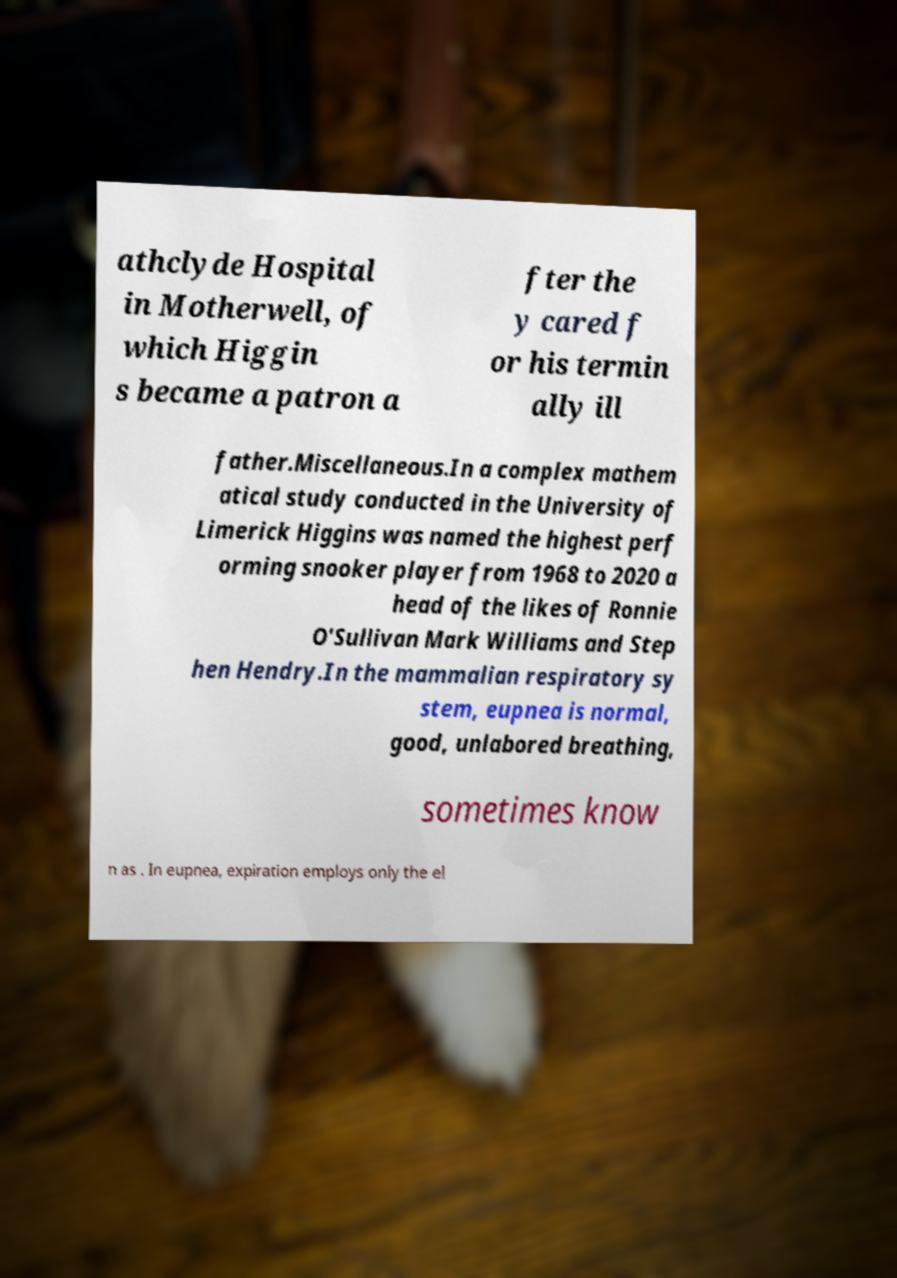Could you extract and type out the text from this image? athclyde Hospital in Motherwell, of which Higgin s became a patron a fter the y cared f or his termin ally ill father.Miscellaneous.In a complex mathem atical study conducted in the University of Limerick Higgins was named the highest perf orming snooker player from 1968 to 2020 a head of the likes of Ronnie O'Sullivan Mark Williams and Step hen Hendry.In the mammalian respiratory sy stem, eupnea is normal, good, unlabored breathing, sometimes know n as . In eupnea, expiration employs only the el 